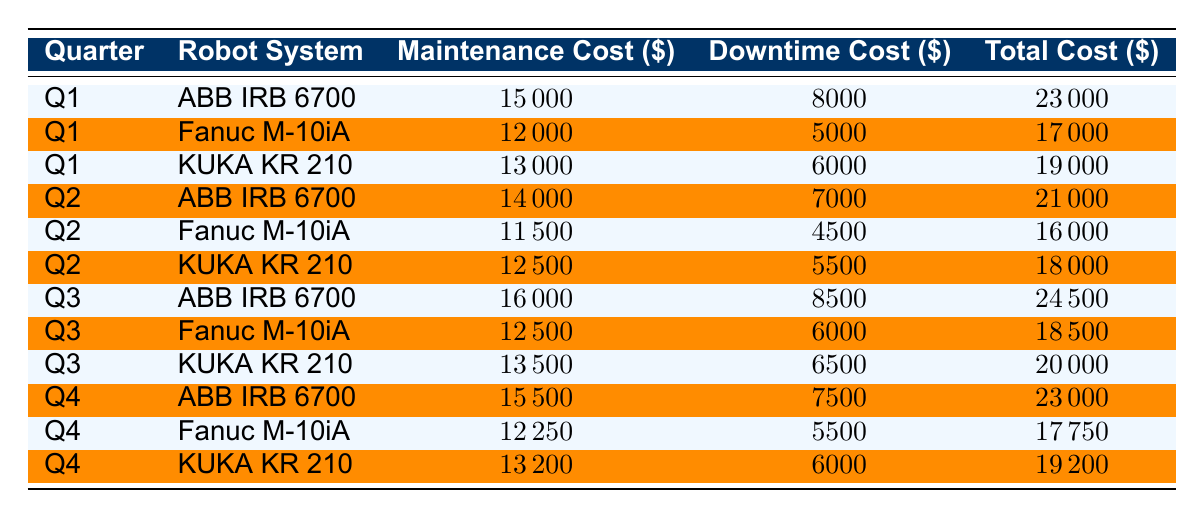What is the total maintenance cost for the ABB IRB 6700 in Q3? In Q3, the maintenance cost for the ABB IRB 6700 is listed as 16000. This information can be directly retrieved from the corresponding row for Q3 in the table.
Answer: 16000 Which robot system incurred the highest total cost in Q1? In Q1, the total costs for each robot system are: ABB IRB 6700 is 23000, Fanuc M-10iA is 17000, and KUKA KR 210 is 19000. The ABB IRB 6700 has the highest total cost among these systems.
Answer: ABB IRB 6700 What is the average downtime cost for the KUKA KR 210 across all quarters? The downtime costs for KUKA KR 210 are: Q1 - 6000, Q2 - 5500, Q3 - 6500, and Q4 - 6000. The total downtime cost is 6000 + 5500 + 6500 + 6000 = 24000. There are 4 quarters, so the average is 24000 / 4 = 6000.
Answer: 6000 Is the maintenance cost of the Fanuc M-10iA higher in Q4 than in Q3? In Q4, the maintenance cost for Fanuc M-10iA is 12250, and in Q3 it is 12500. Since 12250 is less than 12500, the statement is false.
Answer: No What is the total cost for each robot system in Q2, and which one has the lowest total cost? In Q2, the total costs are: ABB IRB 6700 is 21000, Fanuc M-10iA is 16000, and KUKA KR 210 is 18000. The lowest total cost is for Fanuc M-10iA at 16000.
Answer: Fanuc M-10iA What is the difference in total costs between Q1 and Q3 for the KUKA KR 210? For KUKA KR 210, the total cost in Q1 is 19000 and in Q3 is 20000. The difference is 20000 - 19000 = 1000.
Answer: 1000 Did the maintenance cost for the ABB IRB 6700 decrease from Q1 to Q2? The maintenance cost for ABB IRB 6700 in Q1 is 15000 and in Q2 is 14000. Since 14000 is less than 15000, the maintenance cost did decrease.
Answer: Yes What is the cumulative maintenance cost for all robot systems across Q1? The maintenance costs in Q1 are: ABB IRB 6700 (15000) + Fanuc M-10iA (12000) + KUKA KR 210 (13000) = 15000 + 12000 + 13000 = 40000.
Answer: 40000 